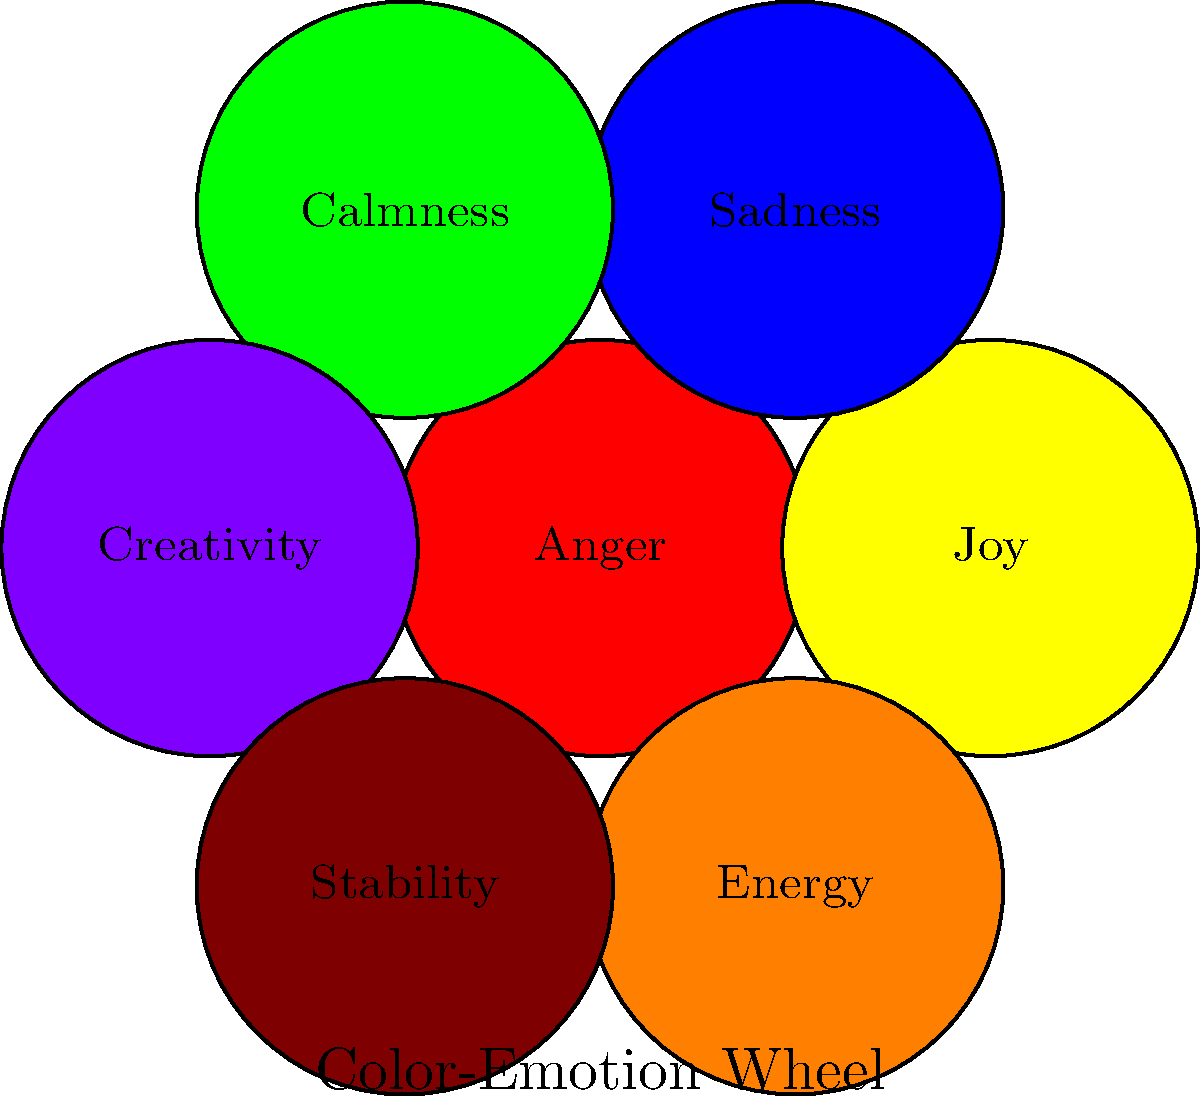In art therapy, which color is commonly associated with feelings of calmness and serenity? To answer this question, let's consider the color-emotion associations commonly used in art therapy:

1. Red is often associated with intense emotions like anger or passion.
2. Yellow typically represents joy, happiness, or optimism.
3. Blue is linked to sadness, but also calmness and serenity.
4. Green is strongly associated with nature, growth, and feelings of calmness.
5. Purple often represents creativity, luxury, or spirituality.
6. Orange is linked to energy and enthusiasm.
7. Brown is associated with stability and groundedness.

In this context, while blue can represent both sadness and calmness, green is more consistently associated with feelings of calmness and serenity. Green's connection to nature often evokes a sense of peace and tranquility, making it the color most commonly used in art therapy to represent and induce feelings of calmness.
Answer: Green 